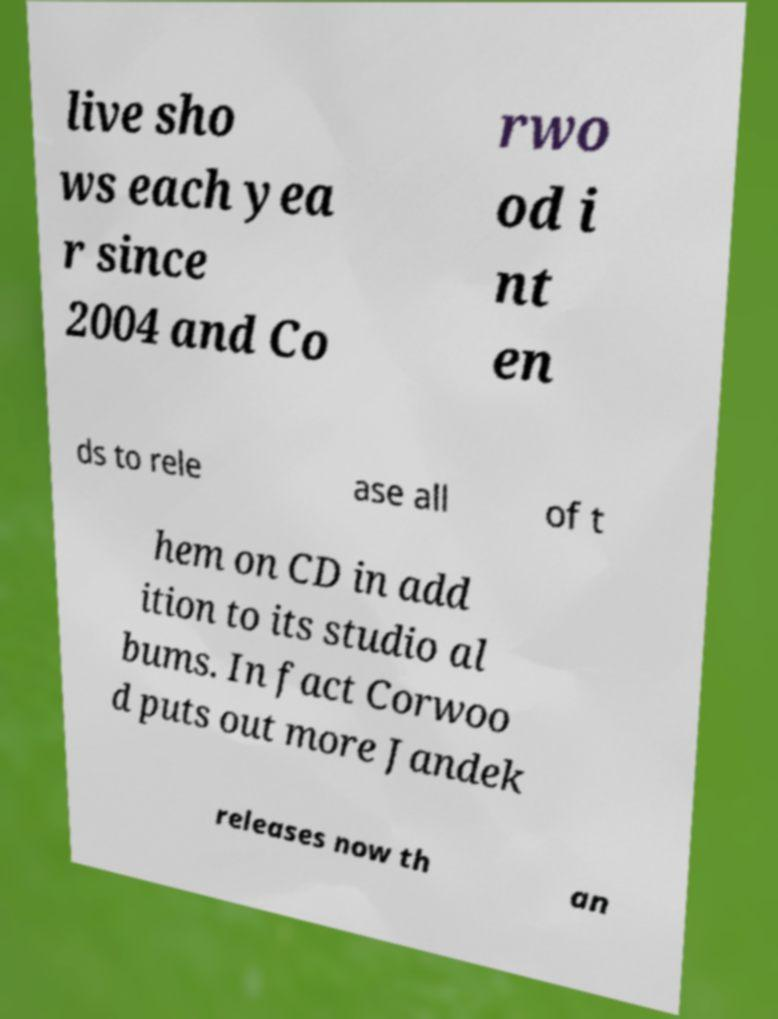I need the written content from this picture converted into text. Can you do that? live sho ws each yea r since 2004 and Co rwo od i nt en ds to rele ase all of t hem on CD in add ition to its studio al bums. In fact Corwoo d puts out more Jandek releases now th an 